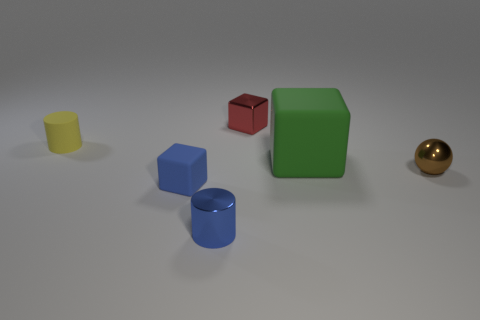What is the shape of the rubber thing that is both on the left side of the big block and right of the yellow rubber thing?
Offer a very short reply. Cube. Are there fewer small blue shiny cylinders behind the tiny shiny cube than blocks?
Offer a very short reply. Yes. What number of large objects are either brown shiny balls or cyan things?
Ensure brevity in your answer.  0. What is the size of the green object?
Your response must be concise. Large. What number of small cubes are left of the blue block?
Ensure brevity in your answer.  0. What size is the other thing that is the same shape as the tiny blue shiny object?
Your response must be concise. Small. There is a metal thing that is both in front of the big green rubber block and to the left of the large green thing; what size is it?
Your response must be concise. Small. There is a shiny sphere; is its color the same as the small cube in front of the red metallic object?
Your response must be concise. No. What number of green things are big cylinders or matte cubes?
Ensure brevity in your answer.  1. The yellow matte object is what shape?
Give a very brief answer. Cylinder. 